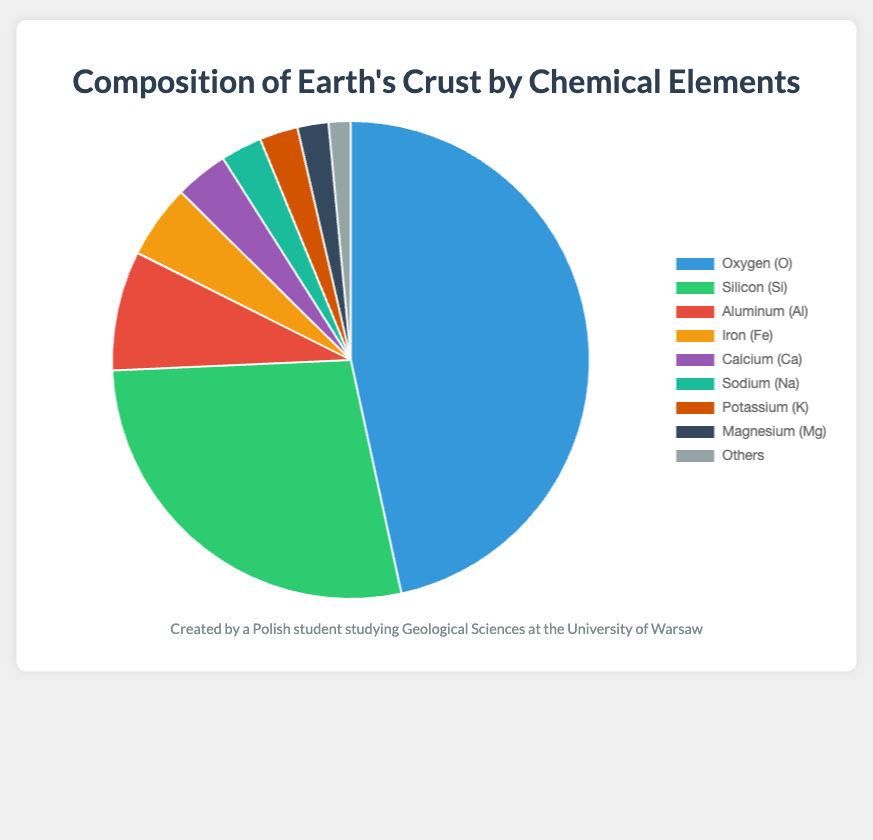What element has the highest percentage in the Earth's crust? The pie chart shows the percentages of various elements in the Earth's crust. Oxygen has the largest slice, indicating it has the highest percentage.
Answer: Oxygen Which element is more abundant in the Earth's crust, Iron or Calcium? By observing the slices for Iron and Calcium in the pie chart, Iron occupies a larger portion compared to Calcium, indicating it is more abundant.
Answer: Iron What is the total percentage of the three most abundant elements in the Earth's crust? The three most abundant elements are Oxygen (46.6%), Silicon (27.7%), and Aluminum (8.1%). Adding these percentages: 46.6 + 27.7 + 8.1 = 82.4.
Answer: 82.4 Which element has the smallest percentage in the pie chart? The pie chart has slices for each element, and the smallest slice represents 'Others' with a percentage of 1.5.
Answer: Others How many percentages greater is Oxygen compared to the combined total of Potassium and Magnesium? Oxygen is 46.6%. Potassium is 2.6% and Magnesium is 2.1%. Their combined total is 2.6 + 2.1 = 4.7%. Subtracting, 46.6 - 4.7 = 41.9%.
Answer: 41.9% By how much does the percentage of Silicon exceed that of Aluminum? Silicon takes up 27.7% and Aluminum 8.1%. Subtracting, 27.7 - 8.1 = 19.6. So, Silicon exceeds Aluminum by 19.6%.
Answer: 19.6 What is the combined percentage of Sodium, Potassium, and Magnesium? Sodium has 2.8%, Potassium has 2.6%, and Magnesium has 2.1%. Adding these percentages: 2.8 + 2.6 + 2.1 = 7.5.
Answer: 7.5 Which elements have an equal or lesser percentage compared to Magnesium? Magnesium's percentage is 2.1%. Both Potassium (2.6%) and Sodium (2.8%) are larger. 'Others' has 1.5%, which is lesser.
Answer: Others What is the average percentage of elements considering Aluminum, Iron, Calcium, and Sodium? Their respective percentages are 8.1 (Al), 5.0 (Fe), 3.6 (Ca), and 2.8 (Na). Adding these values: 8.1 + 5.0 + 3.6 + 2.8 = 19.5. There are 4 elements, so the average is 19.5 / 4 = 4.875.
Answer: 4.875 Which color represents Silicon in the pie chart? Each segment in the pie chart is colored differently with Silicon being near the top left from positions. The color for Silicon is next to Oxygen and appears green.
Answer: Green 